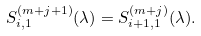<formula> <loc_0><loc_0><loc_500><loc_500>S _ { i , 1 } ^ { ( m + j + 1 ) } ( \lambda ) = S _ { i + 1 , 1 } ^ { ( m + j ) } ( \lambda ) .</formula> 